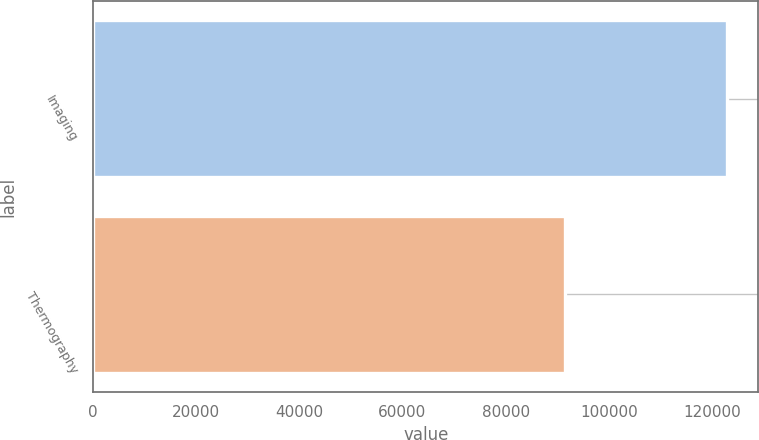Convert chart. <chart><loc_0><loc_0><loc_500><loc_500><bar_chart><fcel>Imaging<fcel>Thermography<nl><fcel>122889<fcel>91484<nl></chart> 